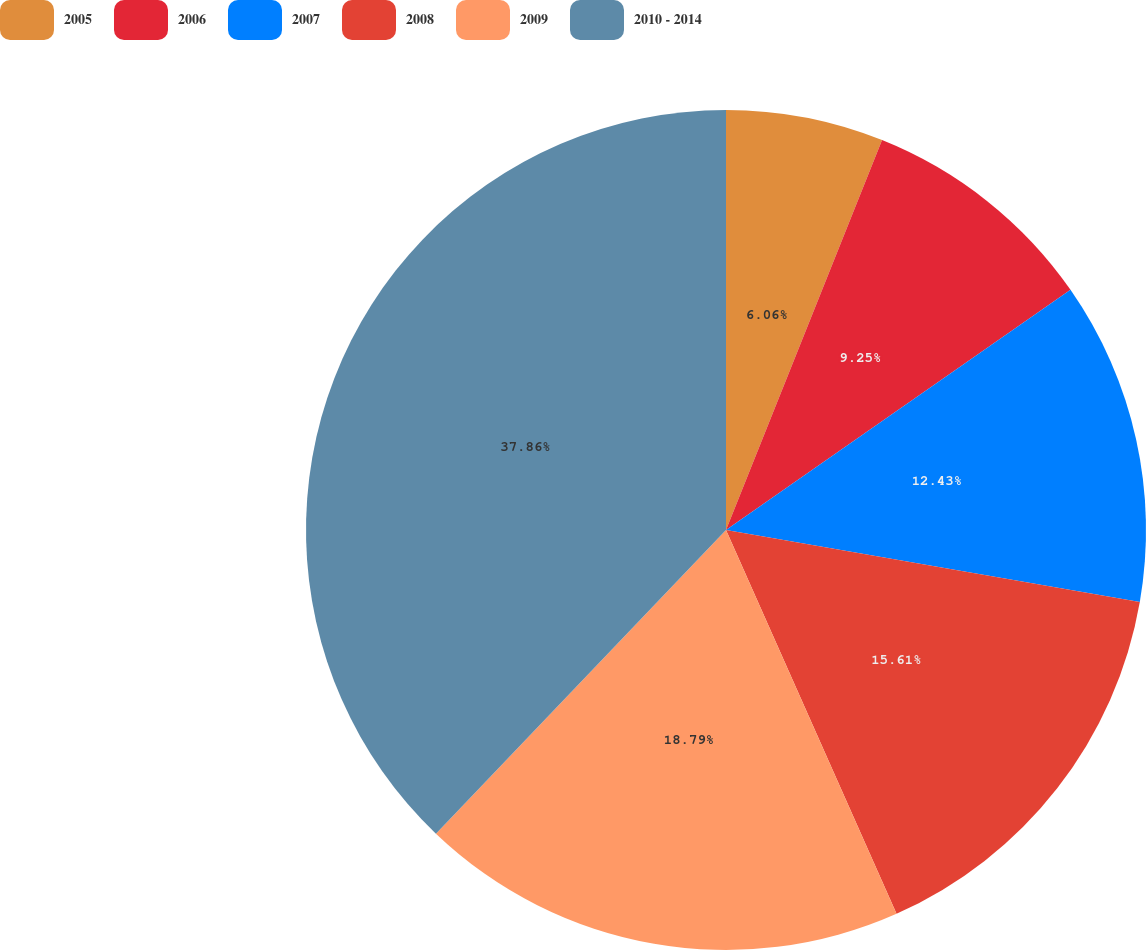<chart> <loc_0><loc_0><loc_500><loc_500><pie_chart><fcel>2005<fcel>2006<fcel>2007<fcel>2008<fcel>2009<fcel>2010 - 2014<nl><fcel>6.06%<fcel>9.25%<fcel>12.43%<fcel>15.61%<fcel>18.79%<fcel>37.87%<nl></chart> 